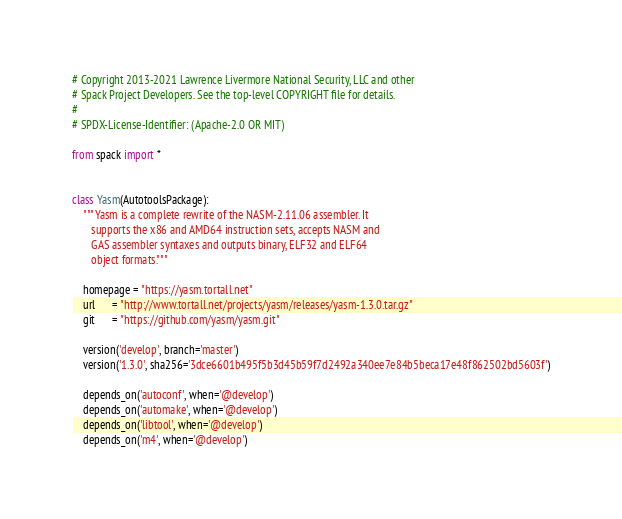<code> <loc_0><loc_0><loc_500><loc_500><_Python_># Copyright 2013-2021 Lawrence Livermore National Security, LLC and other
# Spack Project Developers. See the top-level COPYRIGHT file for details.
#
# SPDX-License-Identifier: (Apache-2.0 OR MIT)

from spack import *


class Yasm(AutotoolsPackage):
    """Yasm is a complete rewrite of the NASM-2.11.06 assembler. It
       supports the x86 and AMD64 instruction sets, accepts NASM and
       GAS assembler syntaxes and outputs binary, ELF32 and ELF64
       object formats."""

    homepage = "https://yasm.tortall.net"
    url      = "http://www.tortall.net/projects/yasm/releases/yasm-1.3.0.tar.gz"
    git      = "https://github.com/yasm/yasm.git"

    version('develop', branch='master')
    version('1.3.0', sha256='3dce6601b495f5b3d45b59f7d2492a340ee7e84b5beca17e48f862502bd5603f')

    depends_on('autoconf', when='@develop')
    depends_on('automake', when='@develop')
    depends_on('libtool', when='@develop')
    depends_on('m4', when='@develop')
</code> 